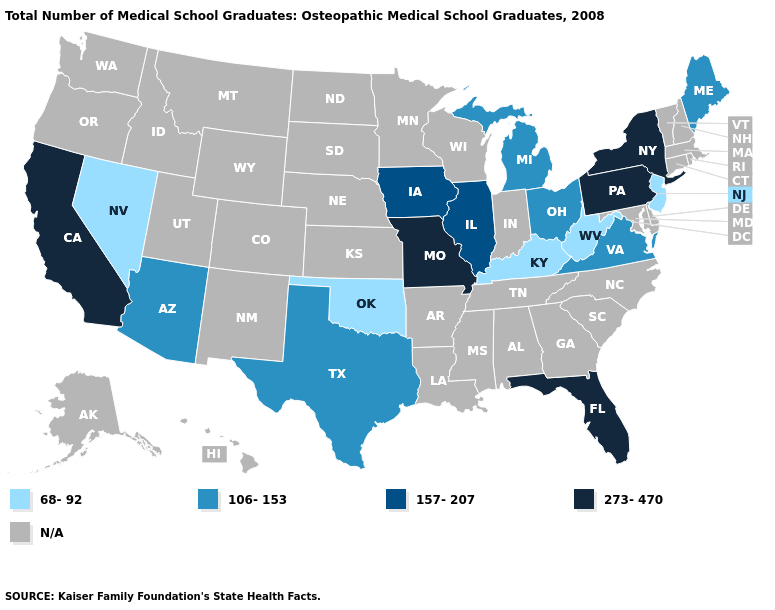What is the value of Florida?
Be succinct. 273-470. Does New York have the highest value in the USA?
Be succinct. Yes. Does Arizona have the lowest value in the West?
Concise answer only. No. What is the lowest value in the South?
Answer briefly. 68-92. What is the value of North Dakota?
Be succinct. N/A. Among the states that border Nevada , which have the lowest value?
Quick response, please. Arizona. What is the value of Delaware?
Be succinct. N/A. What is the value of Kansas?
Write a very short answer. N/A. Does West Virginia have the lowest value in the USA?
Short answer required. Yes. What is the lowest value in the MidWest?
Write a very short answer. 106-153. What is the value of West Virginia?
Quick response, please. 68-92. What is the value of North Dakota?
Quick response, please. N/A. Name the states that have a value in the range 157-207?
Give a very brief answer. Illinois, Iowa. 